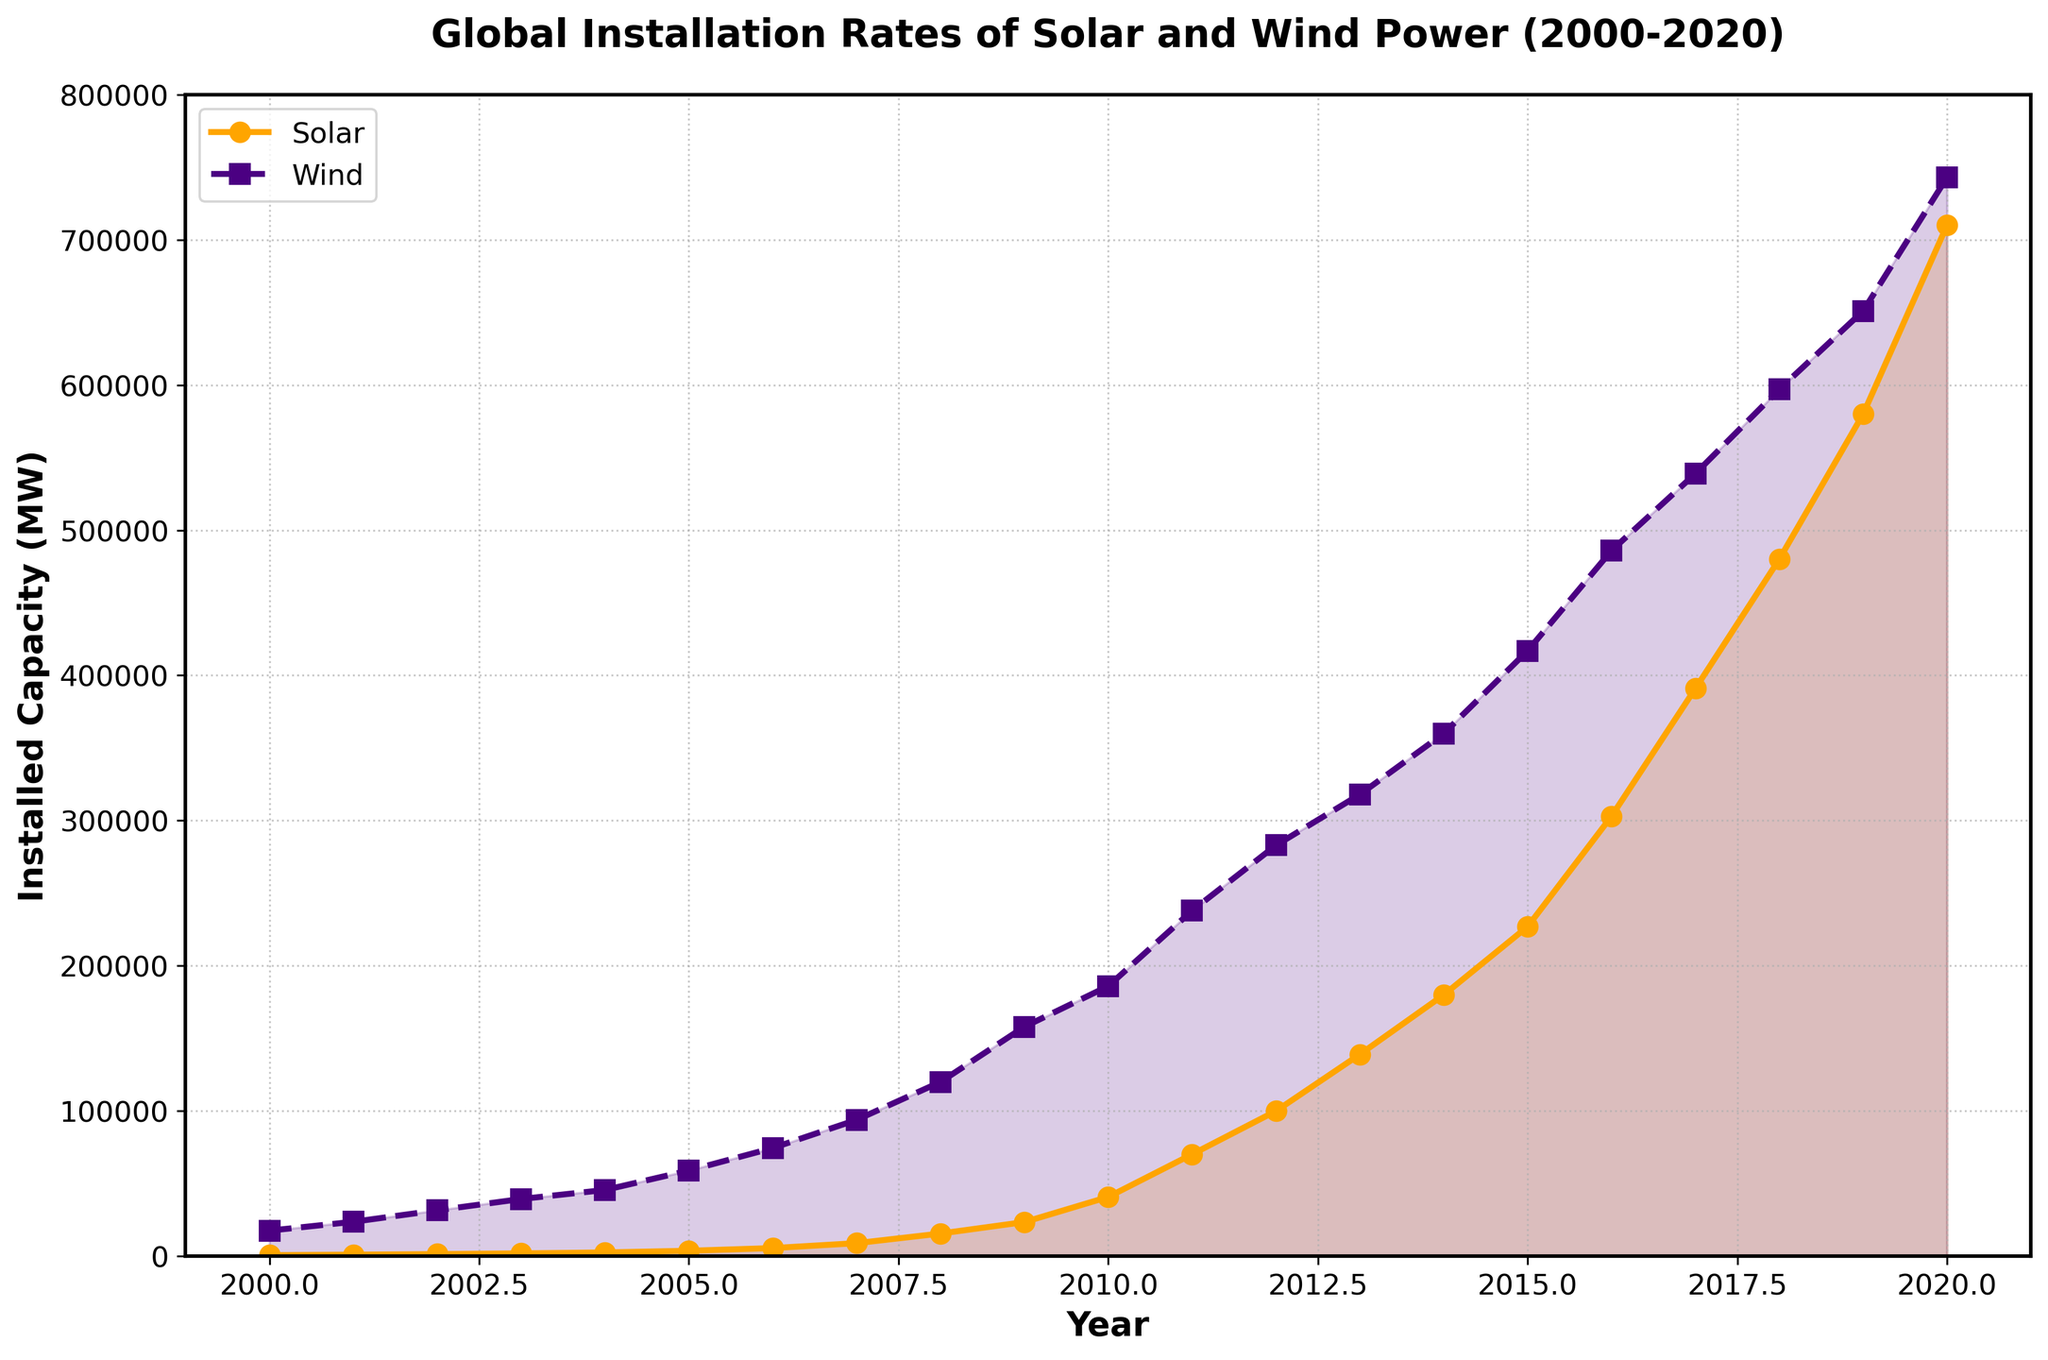What is the title of the plot? The title is usually displayed at the top of a plot. In this figure, it is written in bold text.
Answer: Global Installation Rates of Solar and Wind Power (2000-2020) How many data points are there for solar and wind power each? The data points are marked with symbols on the plot; for solar, it is marked with circles, and for wind, it is marked with squares. Count these markers to get the total number of data points.
Answer: 21 Which year had the highest installed capacity for solar power? Look for the highest point on the line marked by circles, which represents solar power, and check the corresponding year on the x-axis.
Answer: 2020 Between which years did the most significant increase in installed capacity for wind power occur? Observe the line with squares for wind power and identify the segment with the steepest slope. This represents the largest increase over the shortest period.
Answer: 2008-2009 What was the installed capacity of wind power in 2010? Find the year 2010 on the x-axis and check the value corresponding to the line with squares on the y-axis.
Answer: 186000 MW By how much did the solar installed capacity increase from 2015 to 2020? Subtract the solar installed capacity value in 2015 from the capacity value in 2020.
Answer: 710000 MW - 227000 MW = 483000 MW Which had a higher installed capacity in the year 2005, solar or wind power, and by how much? Compare the y-axis values for both solar and wind power in 2005. Subtract the solar power value from the wind power value to determine the difference.
Answer: Wind by 55260 MW What was the average installed capacity of solar power between 2000 and 2005 (inclusive)? Add the solar capacities from 2000 to 2005, then divide the sum by the number of years within that range (2000-2005).
Answer: (722 + 1050 + 1450 + 1950 + 2590 + 3740) / 6 = 1917 MW In which year did solar power's installed capacity first exceed 100000 MW? Look at the line for solar power and find the first year where the y-axis value exceeds 100000 MW.
Answer: 2012 